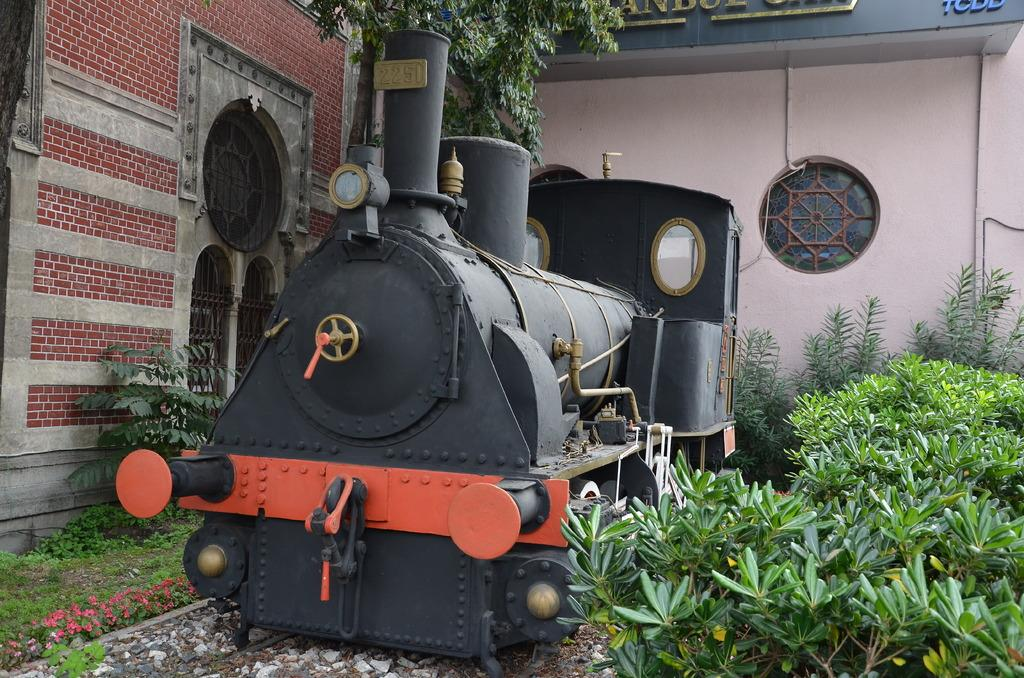What type of toy is in the image? There is a toy rail engine in the image. What color is the toy rail engine? The toy rail engine is black in color. What is located on the left side of the image? There is a brick wall on the left side of the image. What type of vegetation is on the right side of the image? There are bushes on the right side of the image. How many eyes does the toy rail engine have in the image? The toy rail engine does not have eyes, as it is an inanimate object and not a living being. 